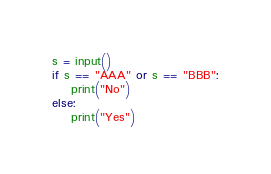<code> <loc_0><loc_0><loc_500><loc_500><_Python_>s = input()
if s == "AAA" or s == "BBB":
    print("No")
else:
    print("Yes")</code> 